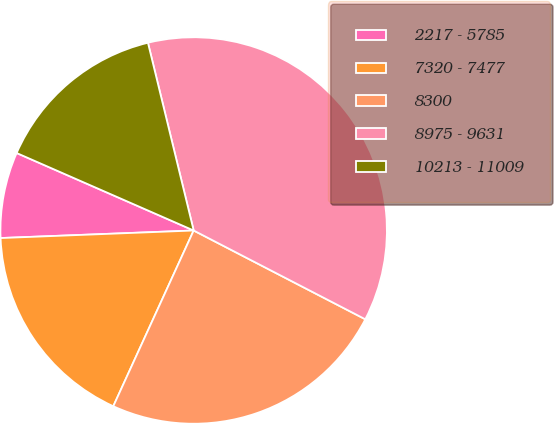Convert chart to OTSL. <chart><loc_0><loc_0><loc_500><loc_500><pie_chart><fcel>2217 - 5785<fcel>7320 - 7477<fcel>8300<fcel>8975 - 9631<fcel>10213 - 11009<nl><fcel>7.19%<fcel>17.55%<fcel>24.23%<fcel>36.4%<fcel>14.63%<nl></chart> 